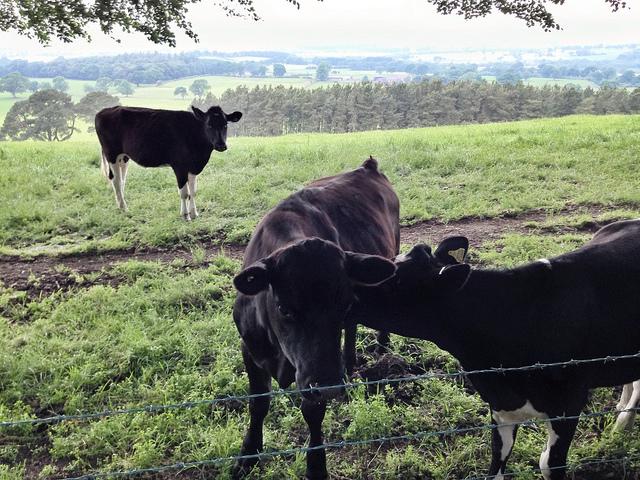Is this animal free?
Keep it brief. No. Where are the animal grazing?
Keep it brief. Field. How many cows are there?
Keep it brief. 3. 